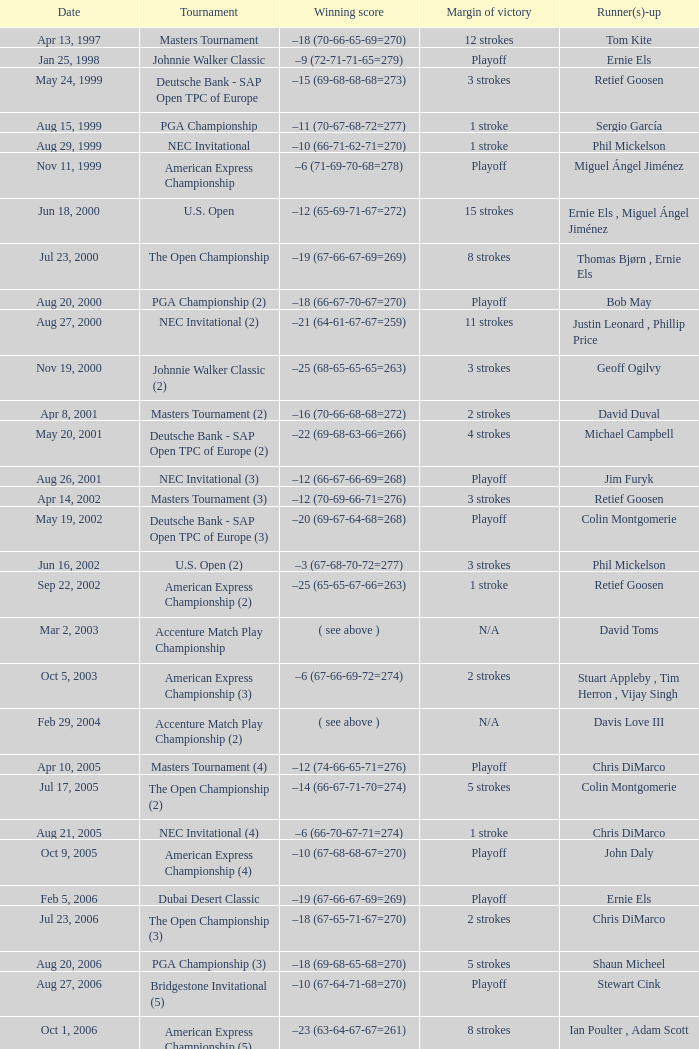Who is Runner(s)-up that has a Date of may 24, 1999? Retief Goosen. 